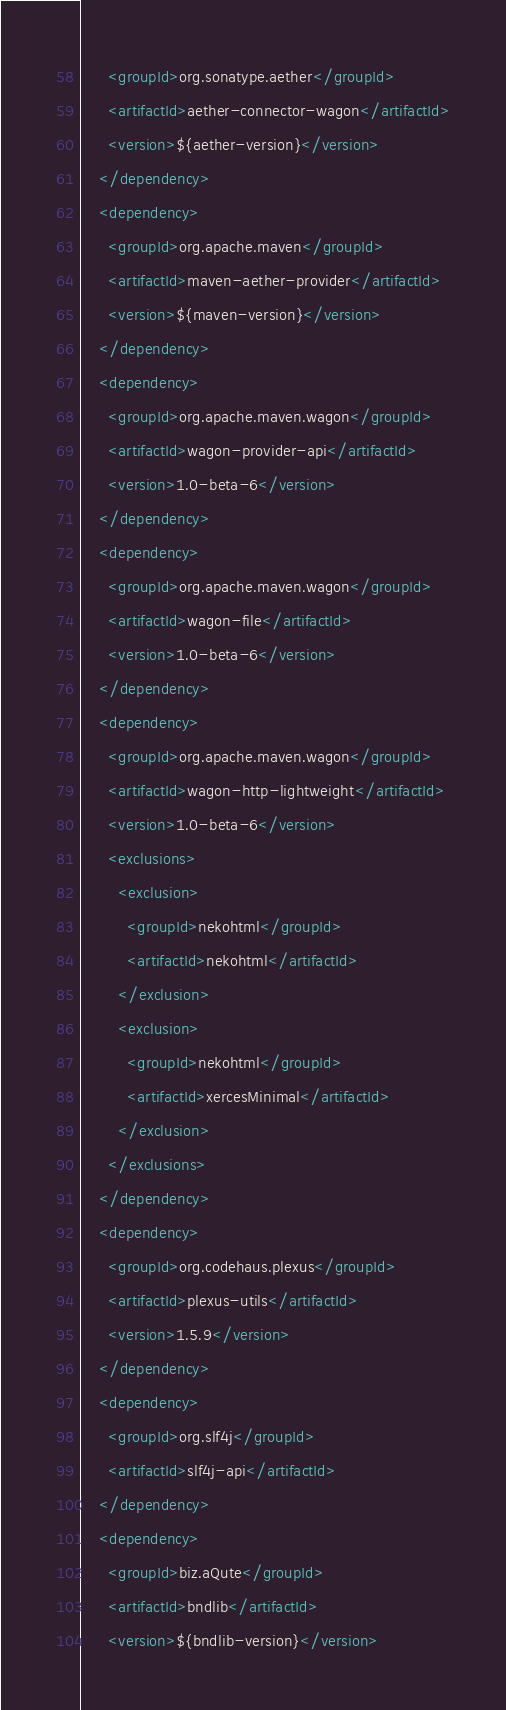Convert code to text. <code><loc_0><loc_0><loc_500><loc_500><_XML_>      <groupId>org.sonatype.aether</groupId>
      <artifactId>aether-connector-wagon</artifactId>
      <version>${aether-version}</version>
    </dependency>
    <dependency>
      <groupId>org.apache.maven</groupId>
      <artifactId>maven-aether-provider</artifactId>
      <version>${maven-version}</version>
    </dependency>
    <dependency>
      <groupId>org.apache.maven.wagon</groupId>
      <artifactId>wagon-provider-api</artifactId>
      <version>1.0-beta-6</version>
    </dependency>
    <dependency>
      <groupId>org.apache.maven.wagon</groupId>
      <artifactId>wagon-file</artifactId>
      <version>1.0-beta-6</version>
    </dependency>
    <dependency>
      <groupId>org.apache.maven.wagon</groupId>
      <artifactId>wagon-http-lightweight</artifactId>
      <version>1.0-beta-6</version>
      <exclusions>
        <exclusion>
          <groupId>nekohtml</groupId>
          <artifactId>nekohtml</artifactId>
        </exclusion>
        <exclusion>
          <groupId>nekohtml</groupId>
          <artifactId>xercesMinimal</artifactId>
        </exclusion>
      </exclusions>
    </dependency>
    <dependency>
      <groupId>org.codehaus.plexus</groupId>
      <artifactId>plexus-utils</artifactId>
      <version>1.5.9</version>
    </dependency>
    <dependency>
      <groupId>org.slf4j</groupId>
      <artifactId>slf4j-api</artifactId>
    </dependency>
    <dependency>
      <groupId>biz.aQute</groupId>
      <artifactId>bndlib</artifactId>
      <version>${bndlib-version}</version></code> 